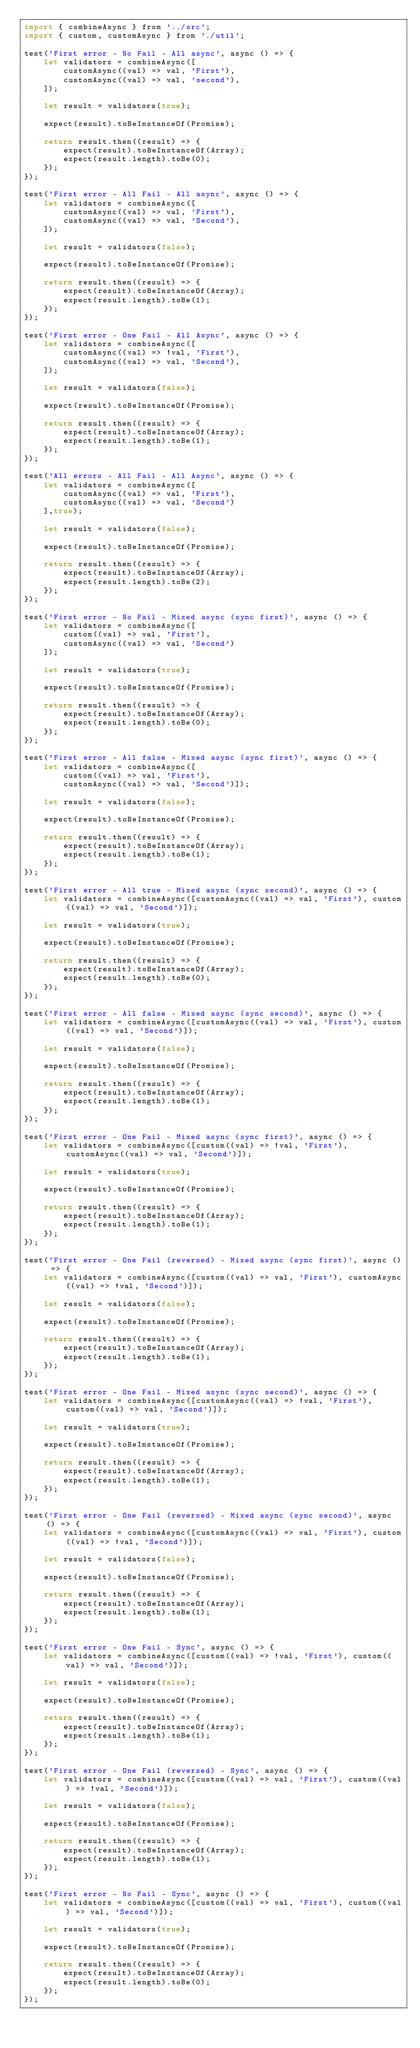Convert code to text. <code><loc_0><loc_0><loc_500><loc_500><_JavaScript_>import { combineAsync } from '../src';
import { custom, customAsync } from './util';

test('First error - No Fail - All async', async () => {
	let validators = combineAsync([
		customAsync((val) => val, 'First'),
		customAsync((val) => val, 'second'),
	]);

	let result = validators(true);

	expect(result).toBeInstanceOf(Promise);

	return result.then((result) => {
		expect(result).toBeInstanceOf(Array);
		expect(result.length).toBe(0);
	});
});

test('First error - All Fail - All async', async () => {
	let validators = combineAsync([
		customAsync((val) => val, 'First'),
		customAsync((val) => val, 'Second'),
	]);

	let result = validators(false);

	expect(result).toBeInstanceOf(Promise);

	return result.then((result) => {
		expect(result).toBeInstanceOf(Array);
		expect(result.length).toBe(1);
	});
});

test('First error - One Fail - All Async', async () => {
	let validators = combineAsync([
		customAsync((val) => !val, 'First'),
		customAsync((val) => val, 'Second'),
	]);

	let result = validators(false);

	expect(result).toBeInstanceOf(Promise);

	return result.then((result) => {
		expect(result).toBeInstanceOf(Array);
		expect(result.length).toBe(1);
	});
});

test('All errors - All Fail - All Async', async () => {
	let validators = combineAsync([
		customAsync((val) => val, 'First'),
		customAsync((val) => val, 'Second')
	],true);

	let result = validators(false);

	expect(result).toBeInstanceOf(Promise);

	return result.then((result) => {
		expect(result).toBeInstanceOf(Array);
		expect(result.length).toBe(2);
	});
});

test('First error - No Fail - Mixed async (sync first)', async () => {
	let validators = combineAsync([
		custom((val) => val, 'First'),
		customAsync((val) => val, 'Second')
	]);

	let result = validators(true);

	expect(result).toBeInstanceOf(Promise);

	return result.then((result) => {
		expect(result).toBeInstanceOf(Array);
		expect(result.length).toBe(0);
	});
});

test('First error - All false - Mixed async (sync first)', async () => {
	let validators = combineAsync([
		custom((val) => val, 'First'),
		customAsync((val) => val, 'Second')]);

	let result = validators(false);

	expect(result).toBeInstanceOf(Promise);

	return result.then((result) => {
		expect(result).toBeInstanceOf(Array);
		expect(result.length).toBe(1);
	});
});

test('First error - All true - Mixed async (sync second)', async () => {
	let validators = combineAsync([customAsync((val) => val, 'First'), custom((val) => val, 'Second')]);

	let result = validators(true);

	expect(result).toBeInstanceOf(Promise);

	return result.then((result) => {
		expect(result).toBeInstanceOf(Array);
		expect(result.length).toBe(0);
	});
});

test('First error - All false - Mixed async (sync second)', async () => {
	let validators = combineAsync([customAsync((val) => val, 'First'), custom((val) => val, 'Second')]);

	let result = validators(false);

	expect(result).toBeInstanceOf(Promise);

	return result.then((result) => {
		expect(result).toBeInstanceOf(Array);
		expect(result.length).toBe(1);
	});
});

test('First error - One Fail - Mixed async (sync first)', async () => {
	let validators = combineAsync([custom((val) => !val, 'First'), customAsync((val) => val, 'Second')]);

	let result = validators(true);

	expect(result).toBeInstanceOf(Promise);

	return result.then((result) => {
		expect(result).toBeInstanceOf(Array);
		expect(result.length).toBe(1);
	});
});

test('First error - One Fail (reversed) - Mixed async (sync first)', async () => {
	let validators = combineAsync([custom((val) => val, 'First'), customAsync((val) => !val, 'Second')]);

	let result = validators(false);

	expect(result).toBeInstanceOf(Promise);

	return result.then((result) => {
		expect(result).toBeInstanceOf(Array);
		expect(result.length).toBe(1);
	});
});

test('First error - One Fail - Mixed async (sync second)', async () => {
	let validators = combineAsync([customAsync((val) => !val, 'First'), custom((val) => val, 'Second')]);

	let result = validators(true);

	expect(result).toBeInstanceOf(Promise);

	return result.then((result) => {
		expect(result).toBeInstanceOf(Array);
		expect(result.length).toBe(1);
	});
});

test('First error - One Fail (reversed) - Mixed async (sync second)', async () => {
	let validators = combineAsync([customAsync((val) => val, 'First'), custom((val) => !val, 'Second')]);

	let result = validators(false);

	expect(result).toBeInstanceOf(Promise);

	return result.then((result) => {
		expect(result).toBeInstanceOf(Array);
		expect(result.length).toBe(1);
	});
});

test('First error - One Fail - Sync', async () => {
	let validators = combineAsync([custom((val) => !val, 'First'), custom((val) => val, 'Second')]);

	let result = validators(false);

	expect(result).toBeInstanceOf(Promise);

	return result.then((result) => {
		expect(result).toBeInstanceOf(Array);
		expect(result.length).toBe(1);
	});
});

test('First error - One Fail (reversed) - Sync', async () => {
	let validators = combineAsync([custom((val) => val, 'First'), custom((val) => !val, 'Second')]);

	let result = validators(false);

	expect(result).toBeInstanceOf(Promise);

	return result.then((result) => {
		expect(result).toBeInstanceOf(Array);
		expect(result.length).toBe(1);
	});
});

test('First error - No Fail - Sync', async () => {
	let validators = combineAsync([custom((val) => val, 'First'), custom((val) => val, 'Second')]);

	let result = validators(true);

	expect(result).toBeInstanceOf(Promise);

	return result.then((result) => {
		expect(result).toBeInstanceOf(Array);
		expect(result.length).toBe(0);
	});
});
</code> 